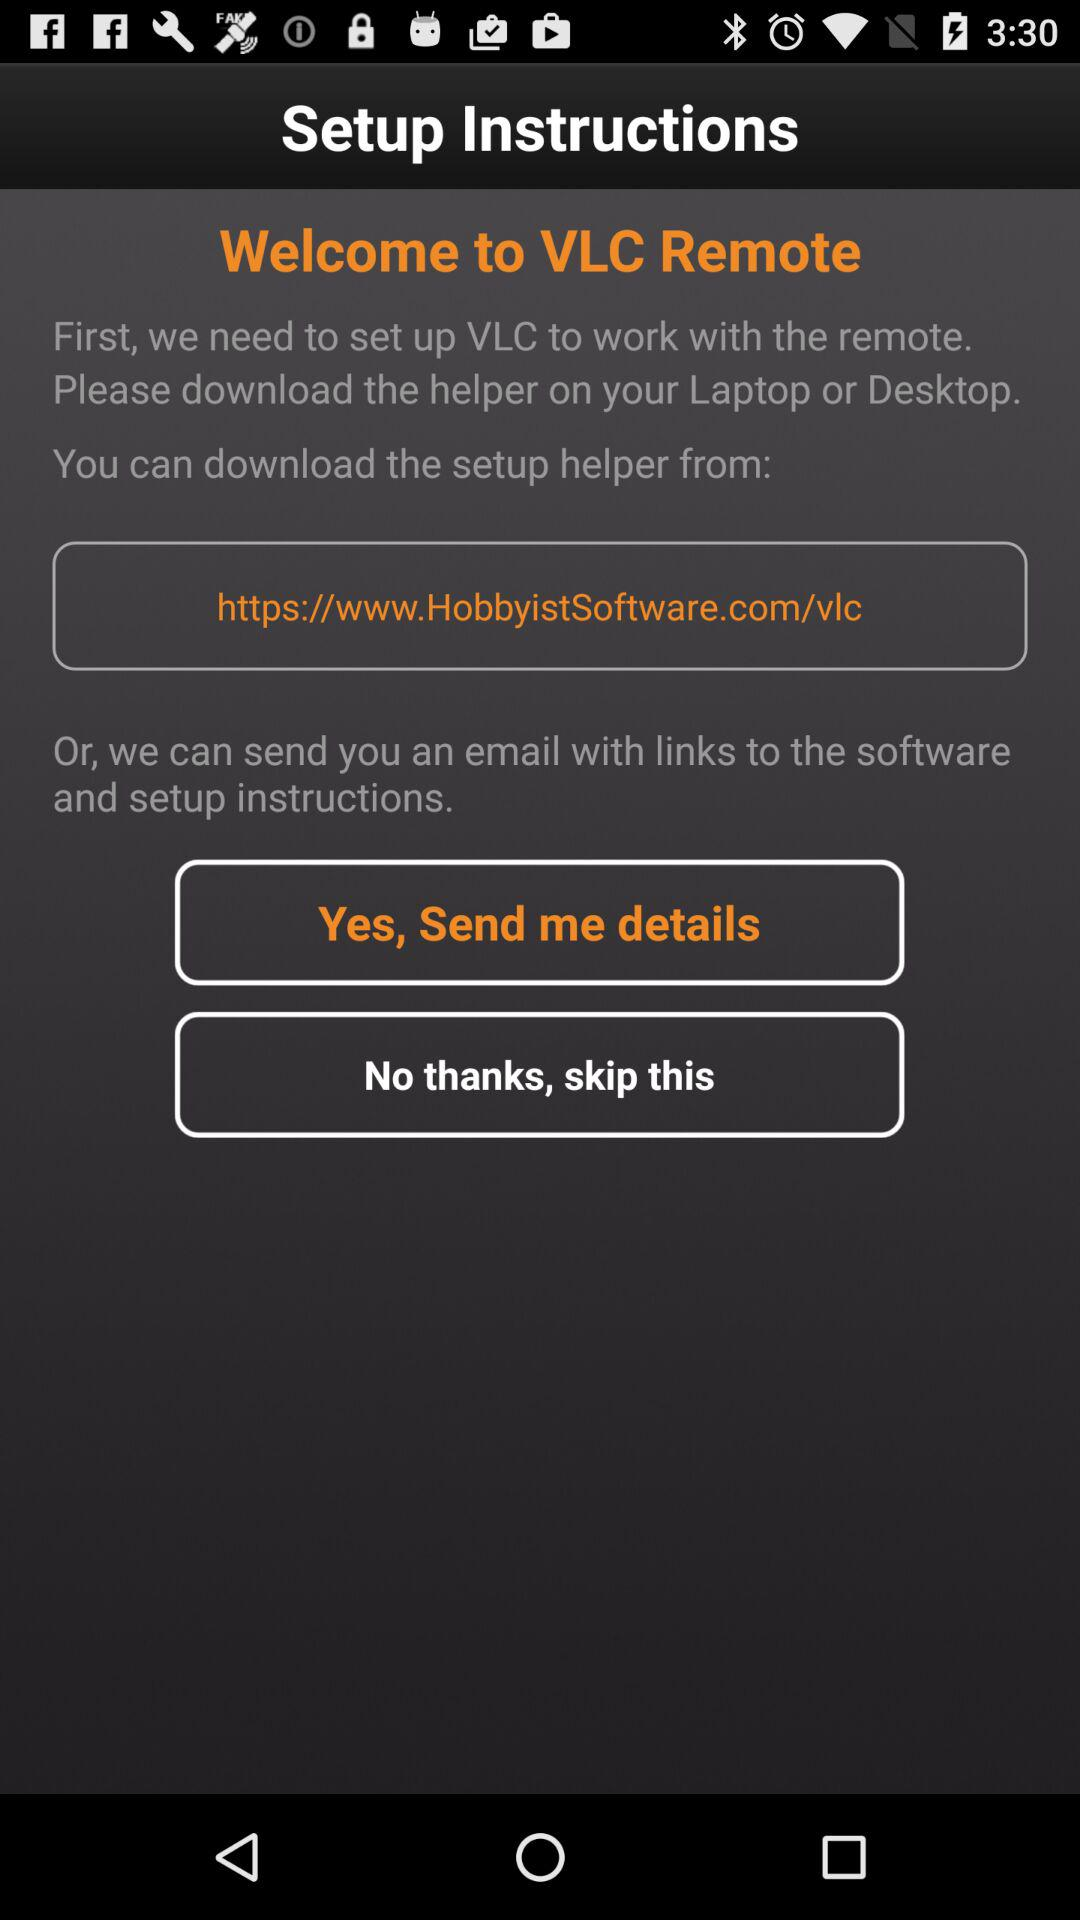How many ways can I set up VLC to work with the remote?
Answer the question using a single word or phrase. 2 